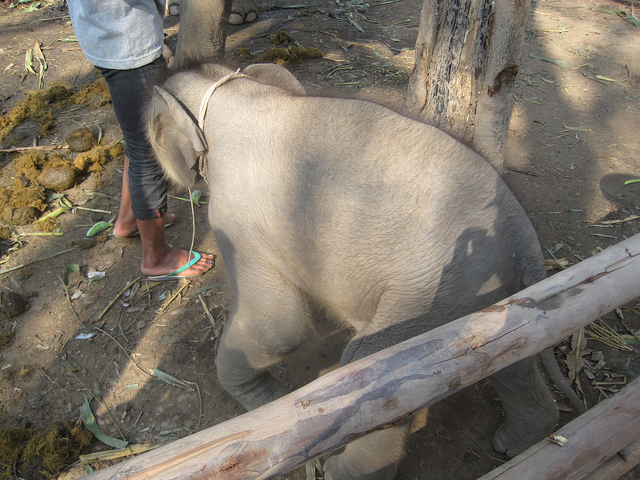<image>What is the creature on top of the animal? I don't know what creature is on top of the animal. It could be a human, bird, bug, fly or there may be no additional creature at all. What is the creature on top of the animal? I don't know what creature is on top of the animal. It can be 'elephant', 'human', 'bird' or 'bug'. 